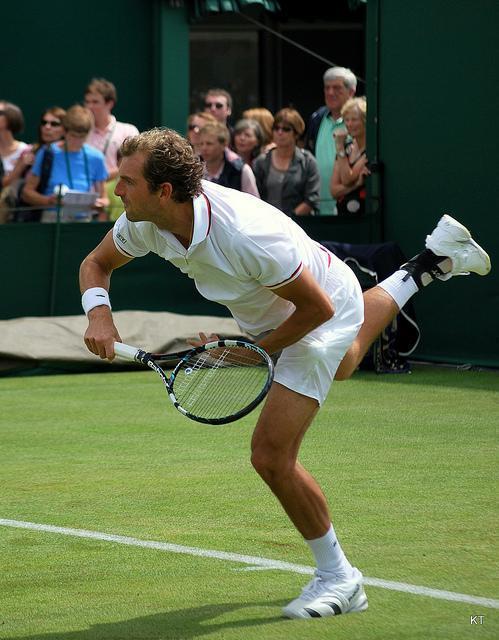How many people can be seen?
Give a very brief answer. 7. 